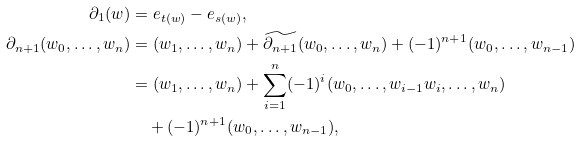Convert formula to latex. <formula><loc_0><loc_0><loc_500><loc_500>\partial _ { 1 } ( w ) & = e _ { t ( w ) } - e _ { s ( w ) } , \\ \partial _ { n + 1 } ( w _ { 0 } , \dots , w _ { n } ) & = ( w _ { 1 } , \dots , w _ { n } ) + \widetilde { \partial _ { n + 1 } } ( w _ { 0 } , \dots , w _ { n } ) + ( - 1 ) ^ { n + 1 } ( w _ { 0 } , \dots , w _ { n - 1 } ) \\ & = ( w _ { 1 } , \dots , w _ { n } ) + \sum _ { i = 1 } ^ { n } ( - 1 ) ^ { i } ( w _ { 0 } , \dots , w _ { i - 1 } w _ { i } , \dots , w _ { n } ) \\ & \quad + ( - 1 ) ^ { n + 1 } ( w _ { 0 } , \dots , w _ { n - 1 } ) ,</formula> 